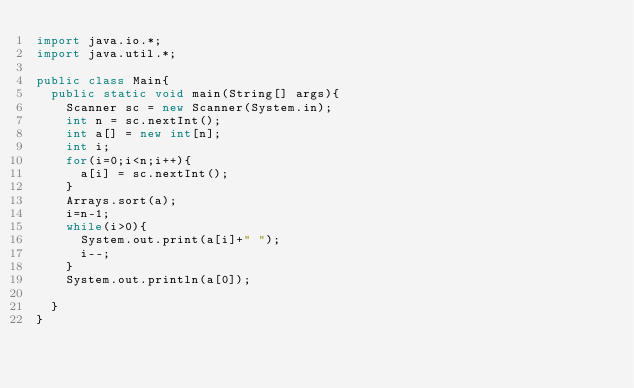Convert code to text. <code><loc_0><loc_0><loc_500><loc_500><_Java_>import java.io.*;
import java.util.*;

public class Main{
	public static void main(String[] args){
		Scanner sc = new Scanner(System.in);
		int n = sc.nextInt();
		int a[] = new int[n];
		int i;
		for(i=0;i<n;i++){
			a[i] = sc.nextInt();
		}
		Arrays.sort(a);
		i=n-1;
		while(i>0){
			System.out.print(a[i]+" ");
			i--;
		}
		System.out.println(a[0]);
		
	}
}</code> 